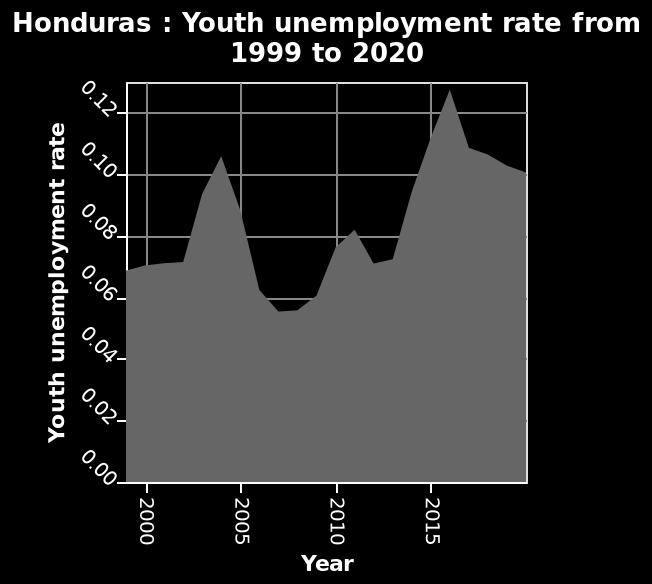<image>
How did the youth unemployment rate change after the spike in 2005?  After the spike in 2005, the youth unemployment rate declined to below 0.05 over the course of a couple of years. When did the spike in youth unemployment rate occur?  The spike in youth unemployment rate occurred just before 2005. Offer a thorough analysis of the image. The youth unemployment rate remains similar for several years after 2000. Just before 2005, the youth unemployment rate spikes from around 0.07 to approximately 0.10. After the spike, it declines to below 0.05 over the course of a couple of years. Youth unemployment then goes on an upward trend until after 2015, peaking above 0.12. It then starts to decline again. Did the decrease in youth unemployment rate occur just before 2005? No. The spike in youth unemployment rate occurred just before 2005. 